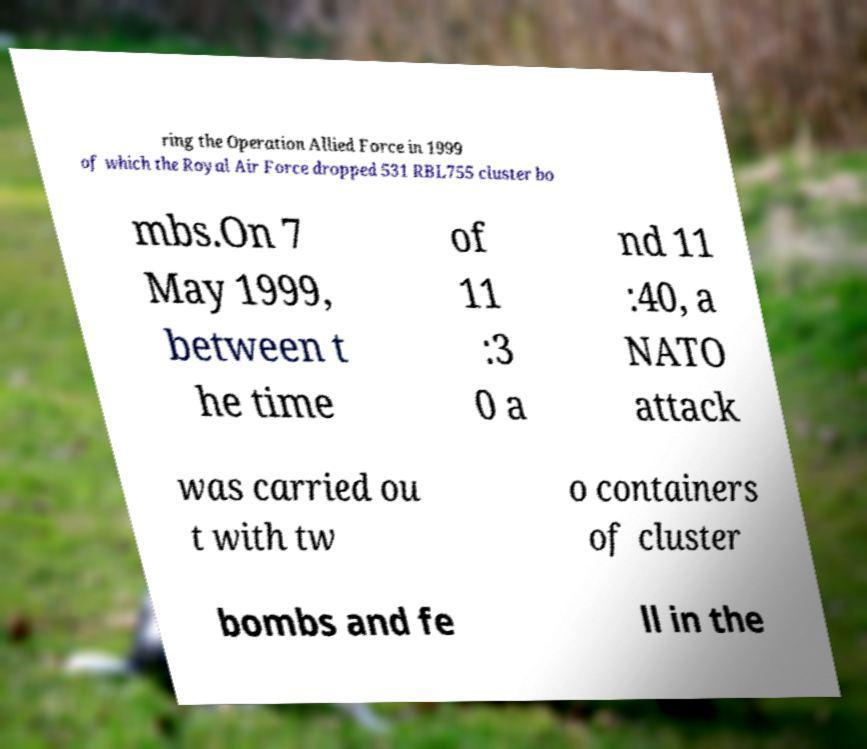Please read and relay the text visible in this image. What does it say? ring the Operation Allied Force in 1999 of which the Royal Air Force dropped 531 RBL755 cluster bo mbs.On 7 May 1999, between t he time of 11 :3 0 a nd 11 :40, a NATO attack was carried ou t with tw o containers of cluster bombs and fe ll in the 